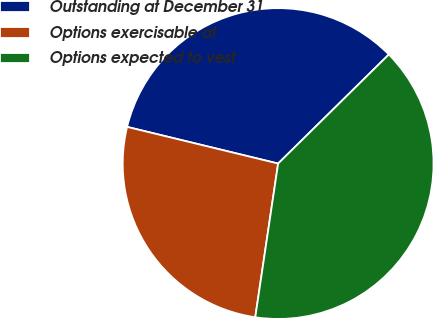Convert chart. <chart><loc_0><loc_0><loc_500><loc_500><pie_chart><fcel>Outstanding at December 31<fcel>Options exercisable at<fcel>Options expected to vest<nl><fcel>33.83%<fcel>26.44%<fcel>39.73%<nl></chart> 